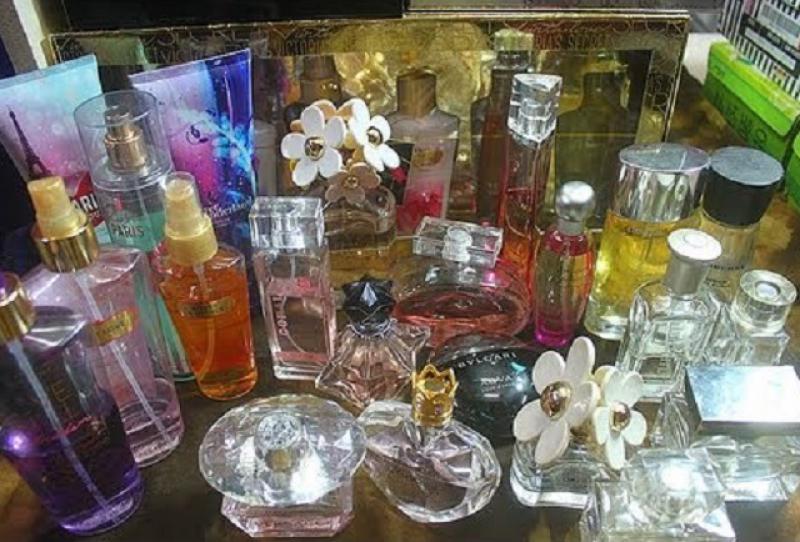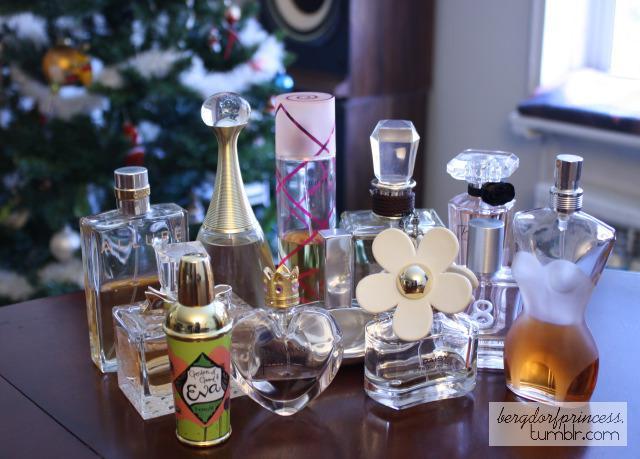The first image is the image on the left, the second image is the image on the right. Evaluate the accuracy of this statement regarding the images: "One of the images contains a bottle of perfume that is shaped like a woman's figure.". Is it true? Answer yes or no. Yes. 